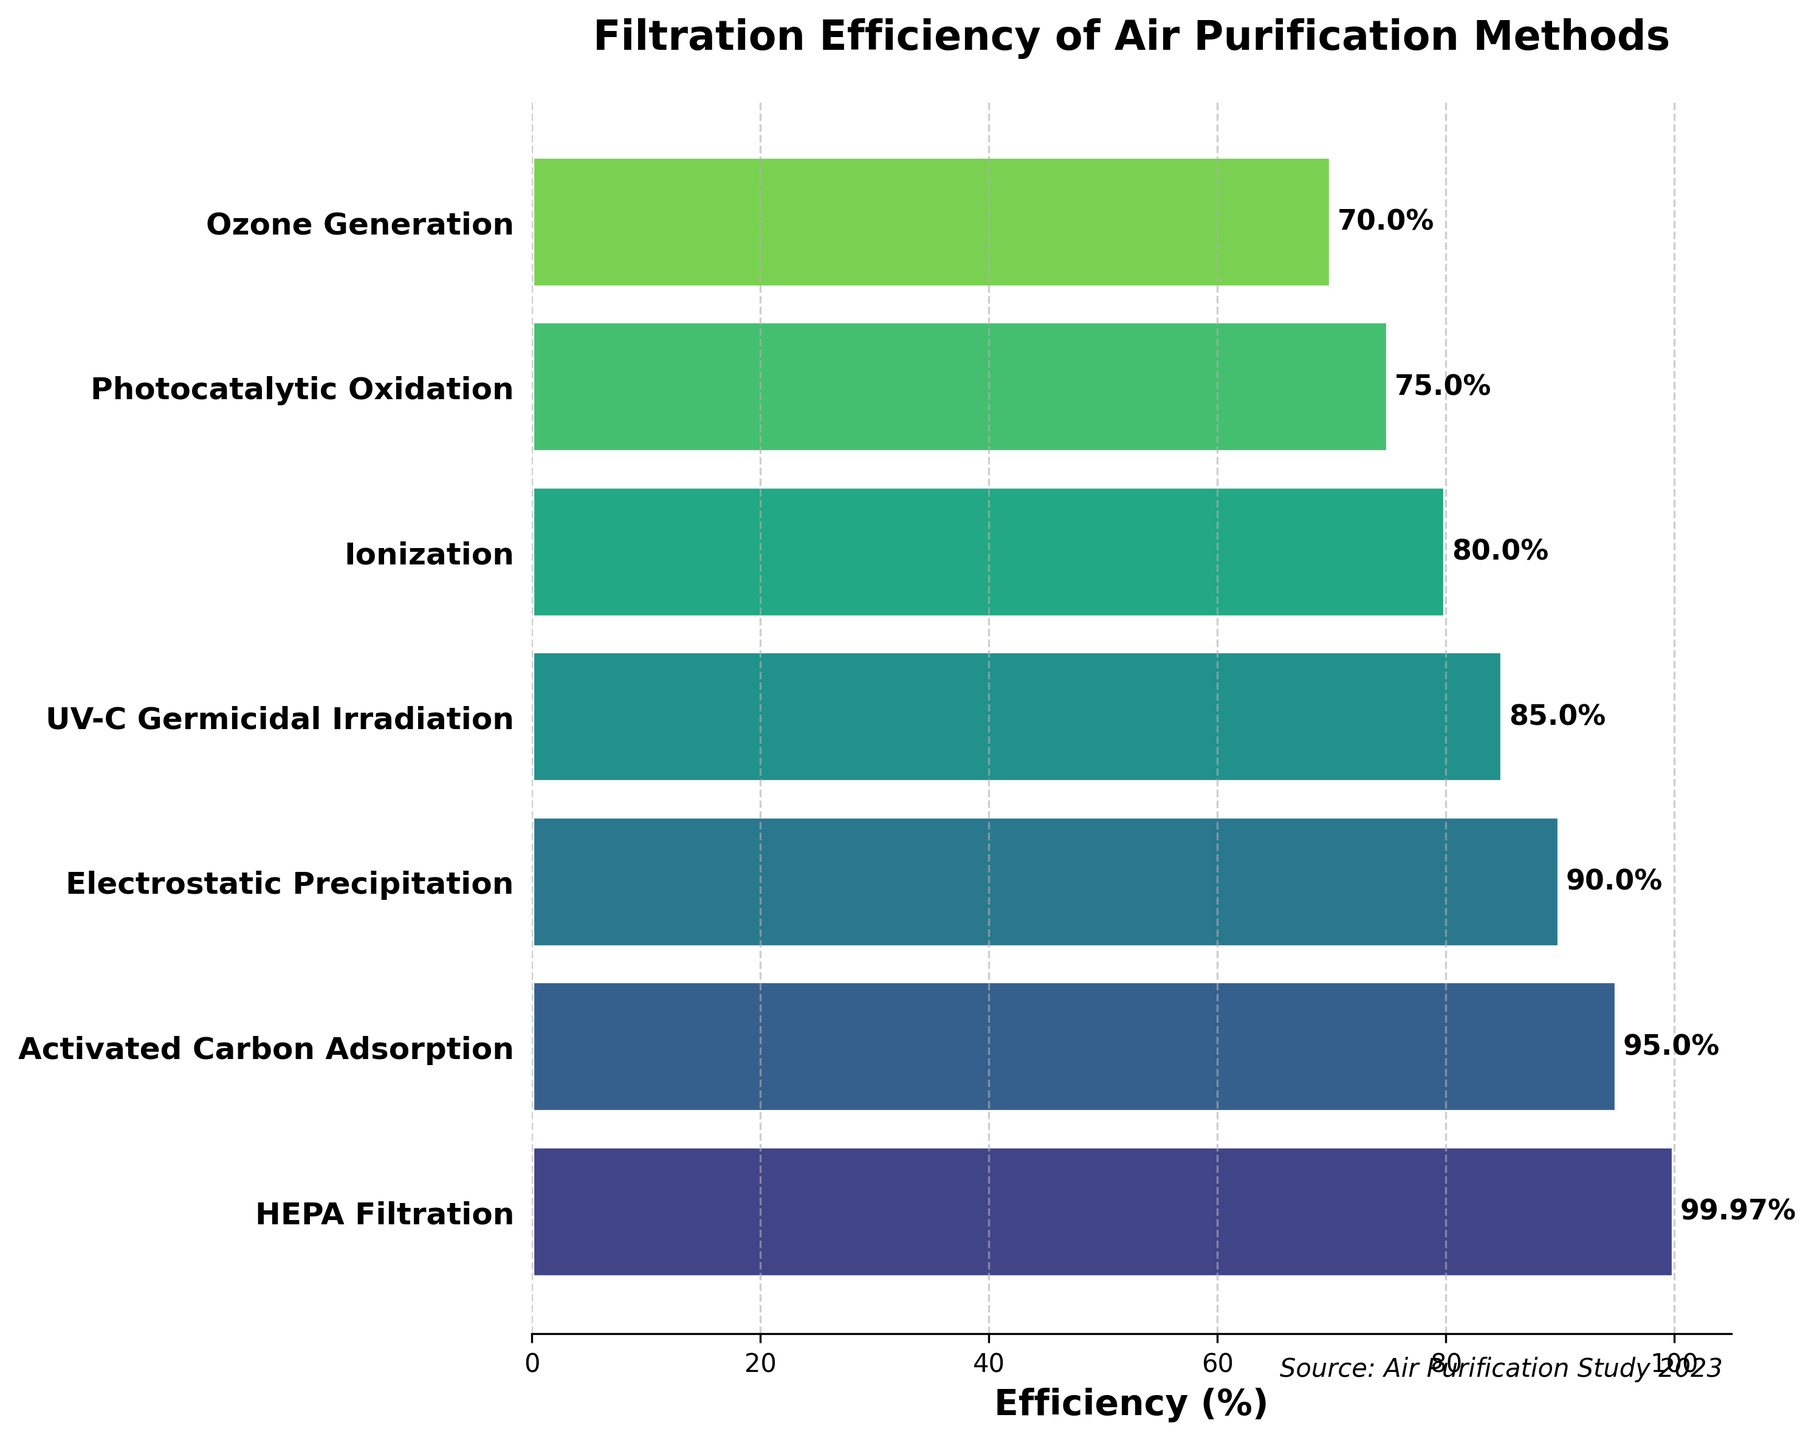What is the title of the figure? The title of the figure can be found at the top of the plot. It reads "Filtration Efficiency of Air Purification Methods".
Answer: Filtration Efficiency of Air Purification Methods Which air purification method has the highest filtration efficiency? By examining the lengths of the horizontal bars, we can see that HEPA Filtration has the longest bar, corresponding to the highest efficiency.
Answer: HEPA Filtration How is data sorted in the chart? Looking at the descending order from the top to the bottom bar, we can discern that the data is sorted by filtration efficiency from highest to lowest.
Answer: By efficiency from highest to lowest What is the filtration efficiency of UV-C Germicidal Irradiation? The bar corresponding to UV-C Germicidal Irradiation shows an efficiency label of 85%.
Answer: 85% How many air purification methods are displayed in the figure? Count the number of horizontal bars or entries listed on the y-axis to determine the number of methods. There are seven methods.
Answer: 7 What is the difference in efficiency between Ionization and Photocatalytic Oxidation? The efficiency of Ionization is 80% and that of Photocatalytic Oxidation is 75%. The difference between them is 80% - 75% = 5%.
Answer: 5% Which method has the least efficiency, and what is its value? The method listed at the bottom of the bar chart, Ozone Generation, has the shortest bar. Its efficiency is labeled as 70%.
Answer: Ozone Generation, 70% What is the average filtration efficiency of all the methods shown? Add all the efficiencies and divide by the number of methods: (99.97% + 95% + 90% + 85% + 80% + 75% + 70%) / 7 = 84.85%.
Answer: 84.85% Which method is more efficient, Electrostatic Precipitation or Activated Carbon Adsorption? Compare the bar lengths and values of Electrostatic Precipitation (90%) and Activated Carbon Adsorption (95%). Activated Carbon Adsorption is more efficient.
Answer: Activated Carbon Adsorption Is there a noticeable gap in efficiency between any two consecutive methods? Analyze the differences between adjacent bars. The biggest noticeable gap appears between HEPA Filtration (99.97%) and Activated Carbon Adsorption (95%), which is a gap of about 4.97%.
Answer: Yes, between HEPA Filtration and Activated Carbon Adsorption 